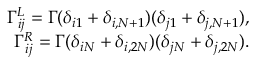Convert formula to latex. <formula><loc_0><loc_0><loc_500><loc_500>\begin{array} { r } { \Gamma _ { i j } ^ { L } = \Gamma ( \delta _ { i 1 } + \delta _ { i , N + 1 } ) ( \delta _ { j 1 } + \delta _ { j , N + 1 } ) , } \\ { \Gamma _ { i j } ^ { R } = \Gamma ( \delta _ { i N } + \delta _ { i , 2 N } ) ( \delta _ { j N } + \delta _ { j , 2 N } ) . } \end{array}</formula> 